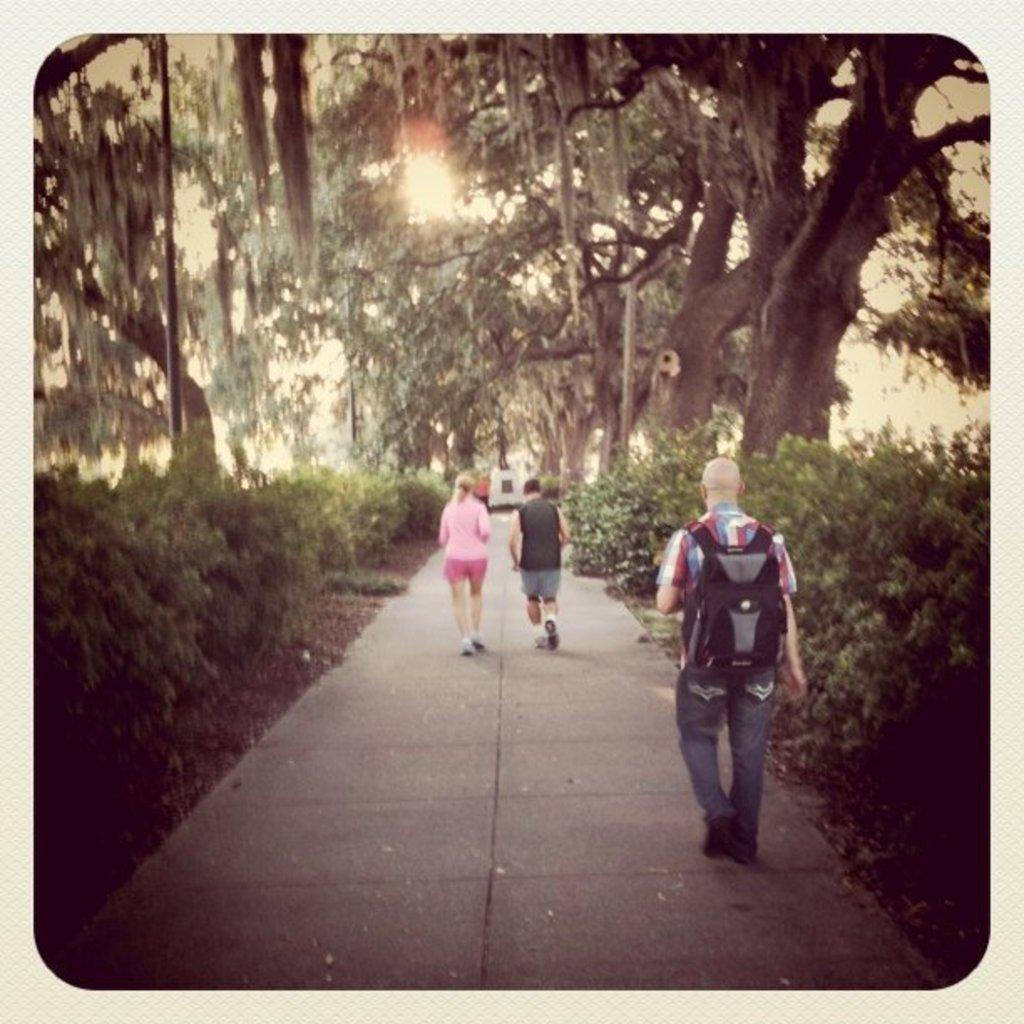What are the people in the image doing? The people in the image are walking. Can you describe the man's appearance in the image? The man is wearing a backpack on his back. What type of natural environment can be seen in the image? There are trees visible in the image. What is the stationary object in the image? There is a statue in the image. What type of knee surgery is the man undergoing in the image? There is no indication of a knee surgery or any medical procedure in the image. The man is simply wearing a backpack. 